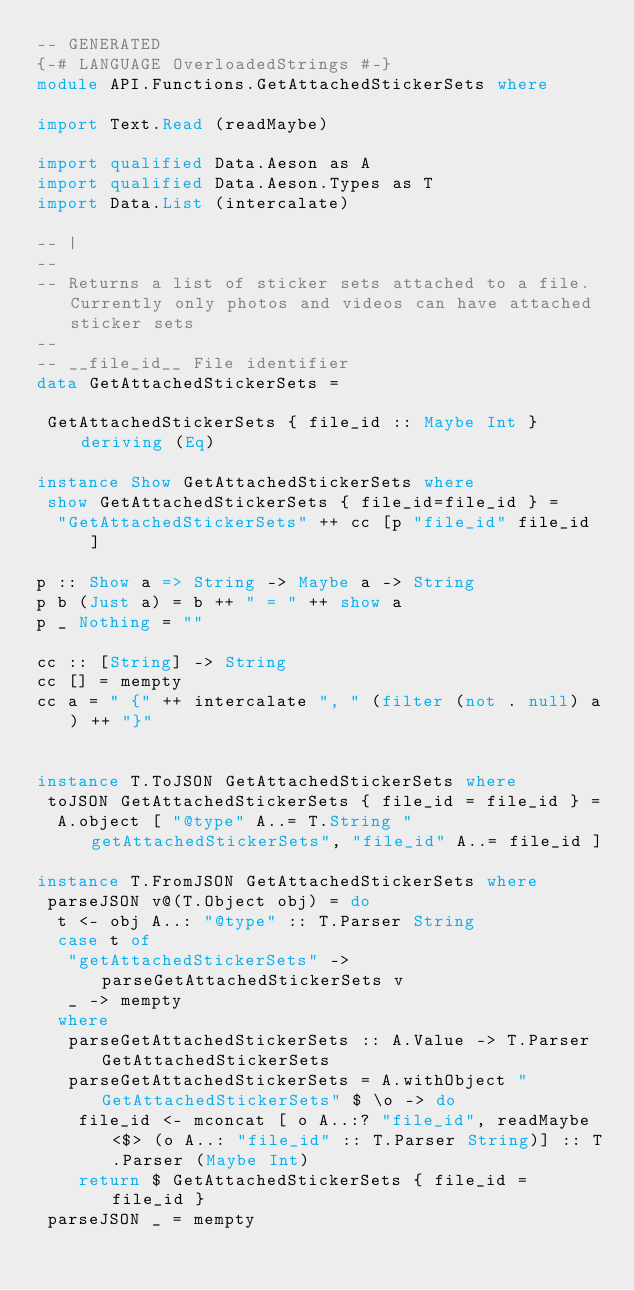<code> <loc_0><loc_0><loc_500><loc_500><_Haskell_>-- GENERATED
{-# LANGUAGE OverloadedStrings #-}
module API.Functions.GetAttachedStickerSets where

import Text.Read (readMaybe)

import qualified Data.Aeson as A
import qualified Data.Aeson.Types as T
import Data.List (intercalate)

-- |
-- 
-- Returns a list of sticker sets attached to a file. Currently only photos and videos can have attached sticker sets 
-- 
-- __file_id__ File identifier
data GetAttachedStickerSets = 

 GetAttachedStickerSets { file_id :: Maybe Int }  deriving (Eq)

instance Show GetAttachedStickerSets where
 show GetAttachedStickerSets { file_id=file_id } =
  "GetAttachedStickerSets" ++ cc [p "file_id" file_id ]

p :: Show a => String -> Maybe a -> String
p b (Just a) = b ++ " = " ++ show a
p _ Nothing = ""

cc :: [String] -> String
cc [] = mempty
cc a = " {" ++ intercalate ", " (filter (not . null) a) ++ "}"


instance T.ToJSON GetAttachedStickerSets where
 toJSON GetAttachedStickerSets { file_id = file_id } =
  A.object [ "@type" A..= T.String "getAttachedStickerSets", "file_id" A..= file_id ]

instance T.FromJSON GetAttachedStickerSets where
 parseJSON v@(T.Object obj) = do
  t <- obj A..: "@type" :: T.Parser String
  case t of
   "getAttachedStickerSets" -> parseGetAttachedStickerSets v
   _ -> mempty
  where
   parseGetAttachedStickerSets :: A.Value -> T.Parser GetAttachedStickerSets
   parseGetAttachedStickerSets = A.withObject "GetAttachedStickerSets" $ \o -> do
    file_id <- mconcat [ o A..:? "file_id", readMaybe <$> (o A..: "file_id" :: T.Parser String)] :: T.Parser (Maybe Int)
    return $ GetAttachedStickerSets { file_id = file_id }
 parseJSON _ = mempty
</code> 